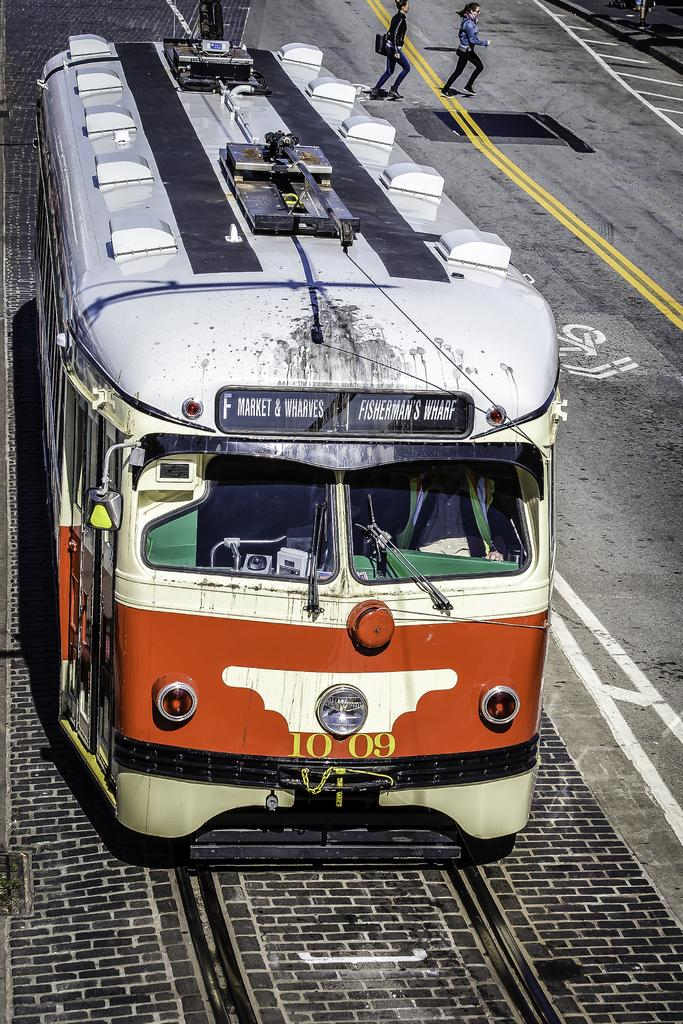What is the main subject of the image? The main subject of the image is a tram. Can you describe the people in the image? There are two persons walking on the road at the top of the image. What type of duck can be seen swimming in the tram? There is no duck present in the image, and the tram is not a body of water where a duck could swim. 